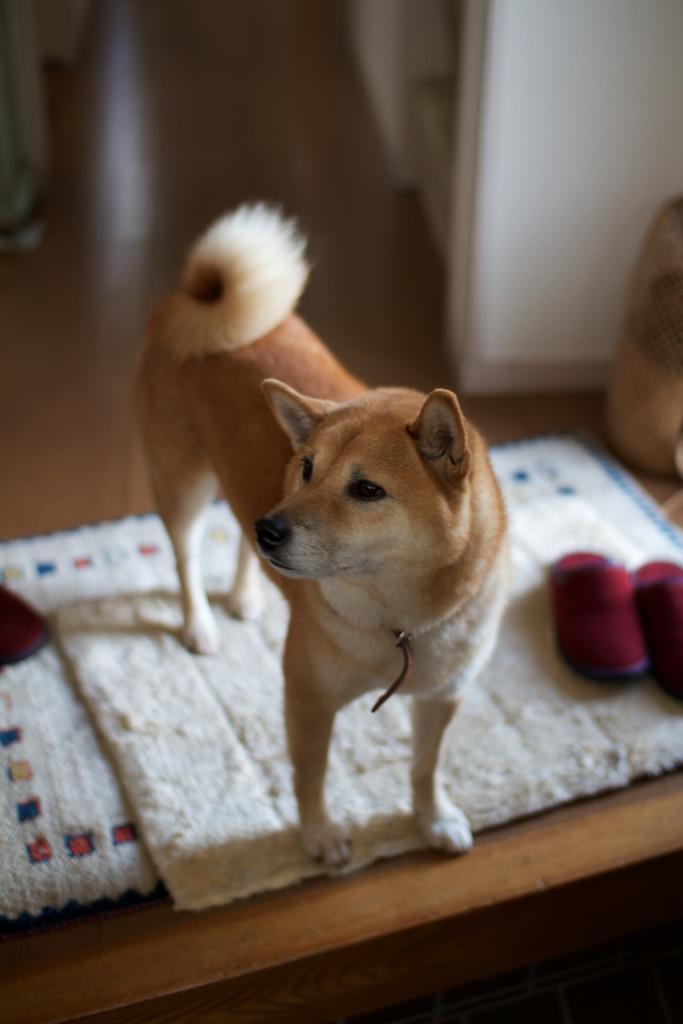Could you give a brief overview of what you see in this image? In the picture we can see a wooden plank on it, we can see some mat which is white in color and a dog standing on it which is brown and white in color and in the background we can see a wooden floor and a white wall. 